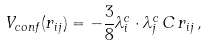Convert formula to latex. <formula><loc_0><loc_0><loc_500><loc_500>V _ { c o n f } ( r _ { i j } ) = - \frac { 3 } { 8 } \lambda _ { i } ^ { c } \cdot \lambda _ { j } ^ { c } \, C \, r _ { i j } \, ,</formula> 